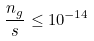Convert formula to latex. <formula><loc_0><loc_0><loc_500><loc_500>\frac { n _ { g } } { s } \leq 1 0 ^ { - 1 4 }</formula> 